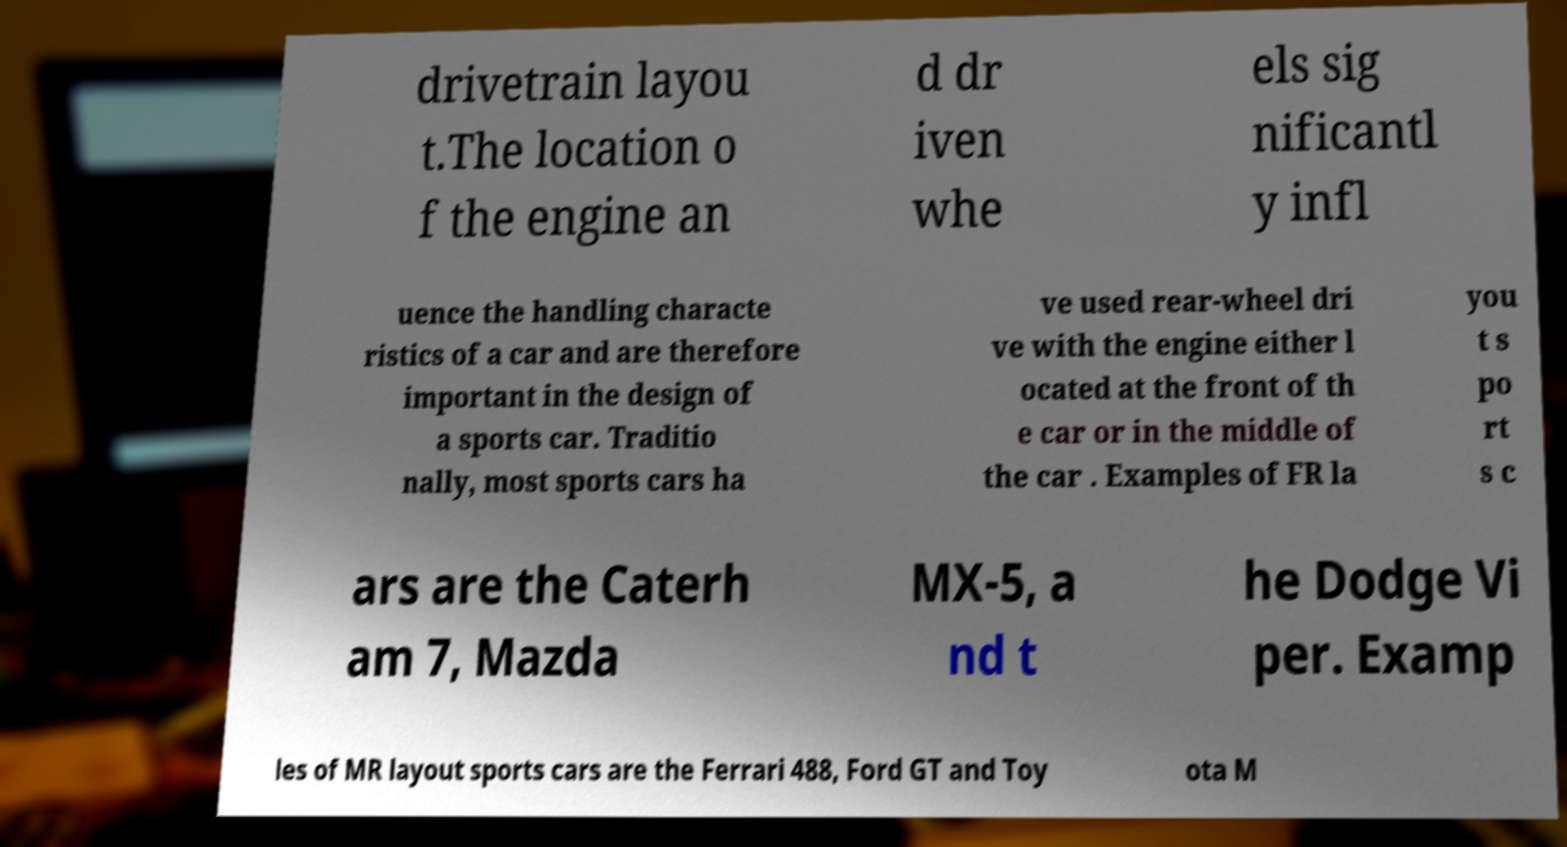Could you assist in decoding the text presented in this image and type it out clearly? drivetrain layou t.The location o f the engine an d dr iven whe els sig nificantl y infl uence the handling characte ristics of a car and are therefore important in the design of a sports car. Traditio nally, most sports cars ha ve used rear-wheel dri ve with the engine either l ocated at the front of th e car or in the middle of the car . Examples of FR la you t s po rt s c ars are the Caterh am 7, Mazda MX-5, a nd t he Dodge Vi per. Examp les of MR layout sports cars are the Ferrari 488, Ford GT and Toy ota M 